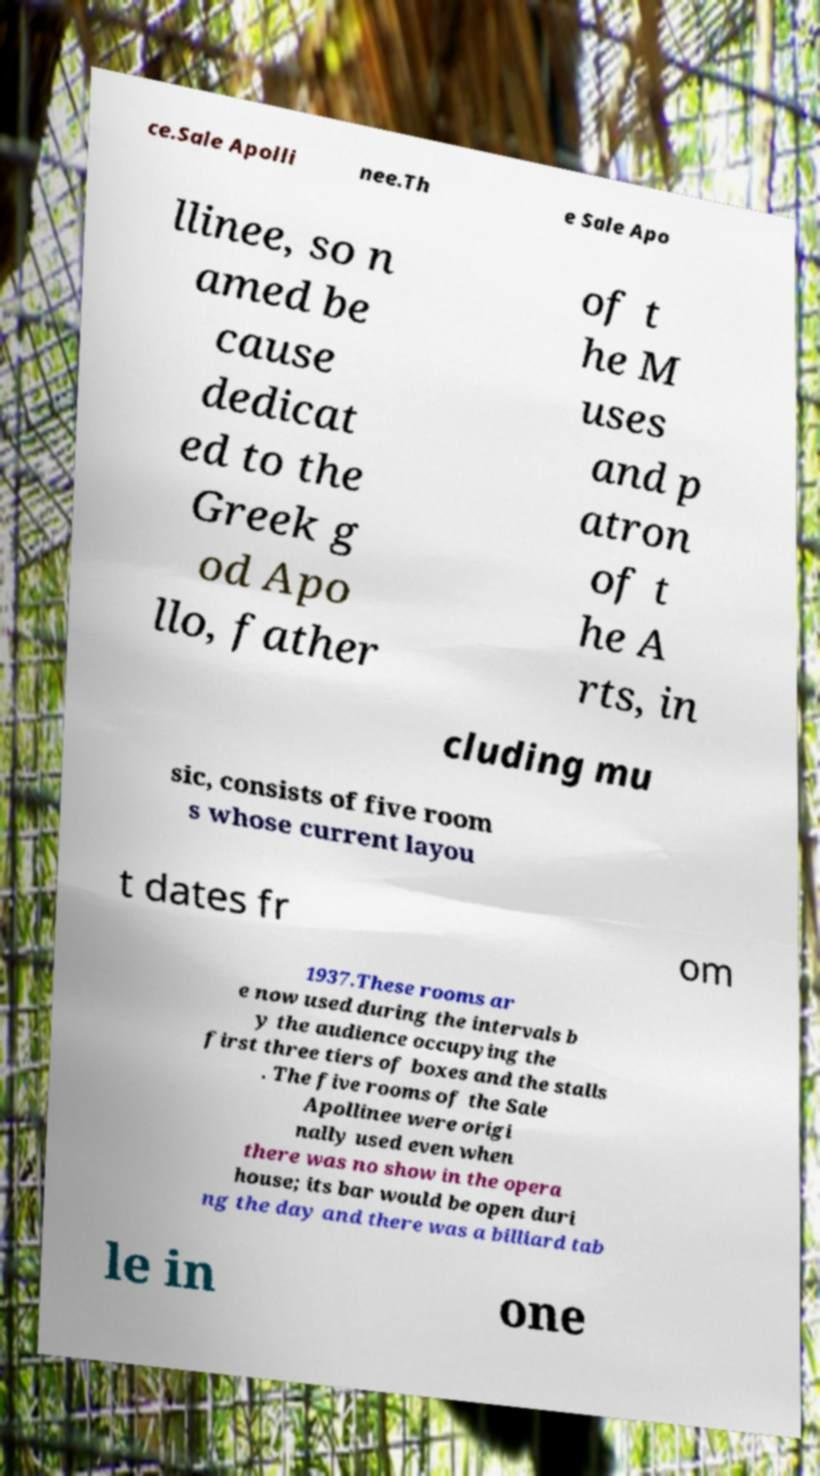Can you read and provide the text displayed in the image?This photo seems to have some interesting text. Can you extract and type it out for me? ce.Sale Apolli nee.Th e Sale Apo llinee, so n amed be cause dedicat ed to the Greek g od Apo llo, father of t he M uses and p atron of t he A rts, in cluding mu sic, consists of five room s whose current layou t dates fr om 1937.These rooms ar e now used during the intervals b y the audience occupying the first three tiers of boxes and the stalls . The five rooms of the Sale Apollinee were origi nally used even when there was no show in the opera house; its bar would be open duri ng the day and there was a billiard tab le in one 